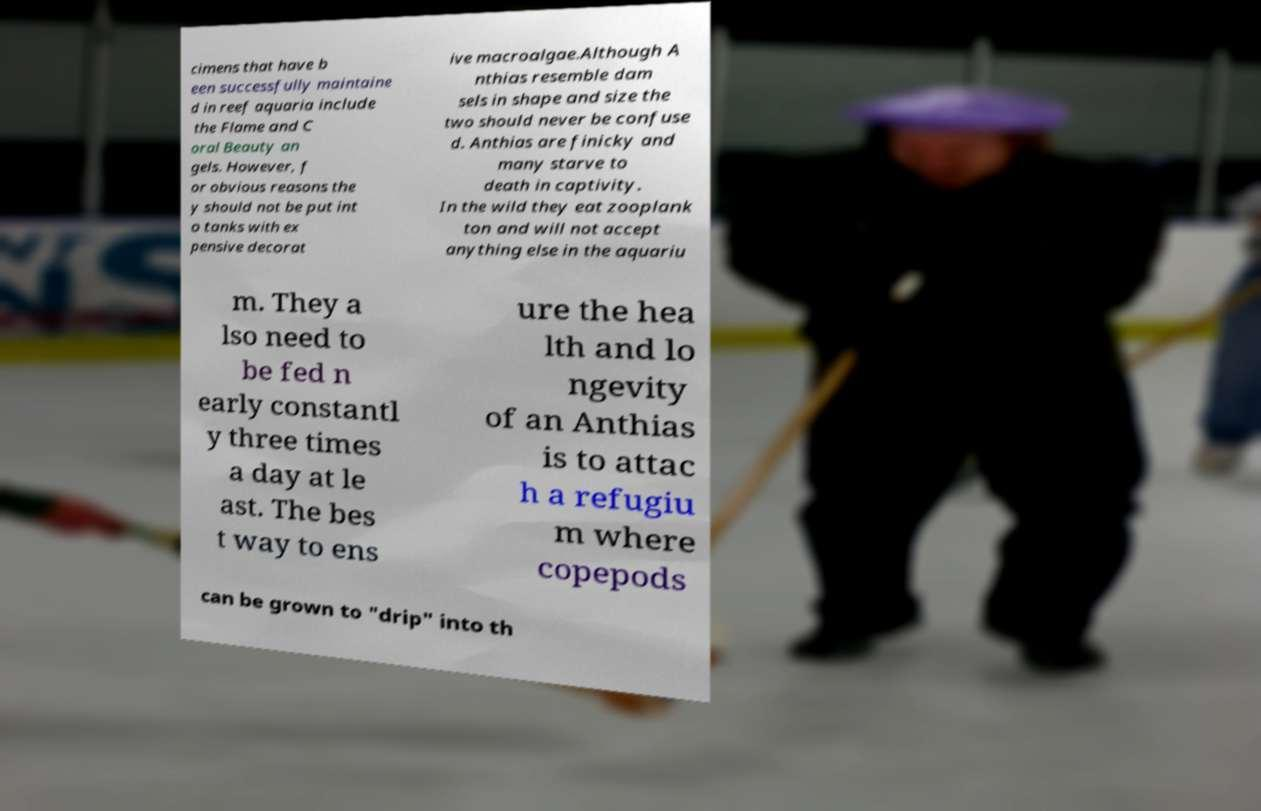For documentation purposes, I need the text within this image transcribed. Could you provide that? cimens that have b een successfully maintaine d in reef aquaria include the Flame and C oral Beauty an gels. However, f or obvious reasons the y should not be put int o tanks with ex pensive decorat ive macroalgae.Although A nthias resemble dam sels in shape and size the two should never be confuse d. Anthias are finicky and many starve to death in captivity. In the wild they eat zooplank ton and will not accept anything else in the aquariu m. They a lso need to be fed n early constantl y three times a day at le ast. The bes t way to ens ure the hea lth and lo ngevity of an Anthias is to attac h a refugiu m where copepods can be grown to "drip" into th 